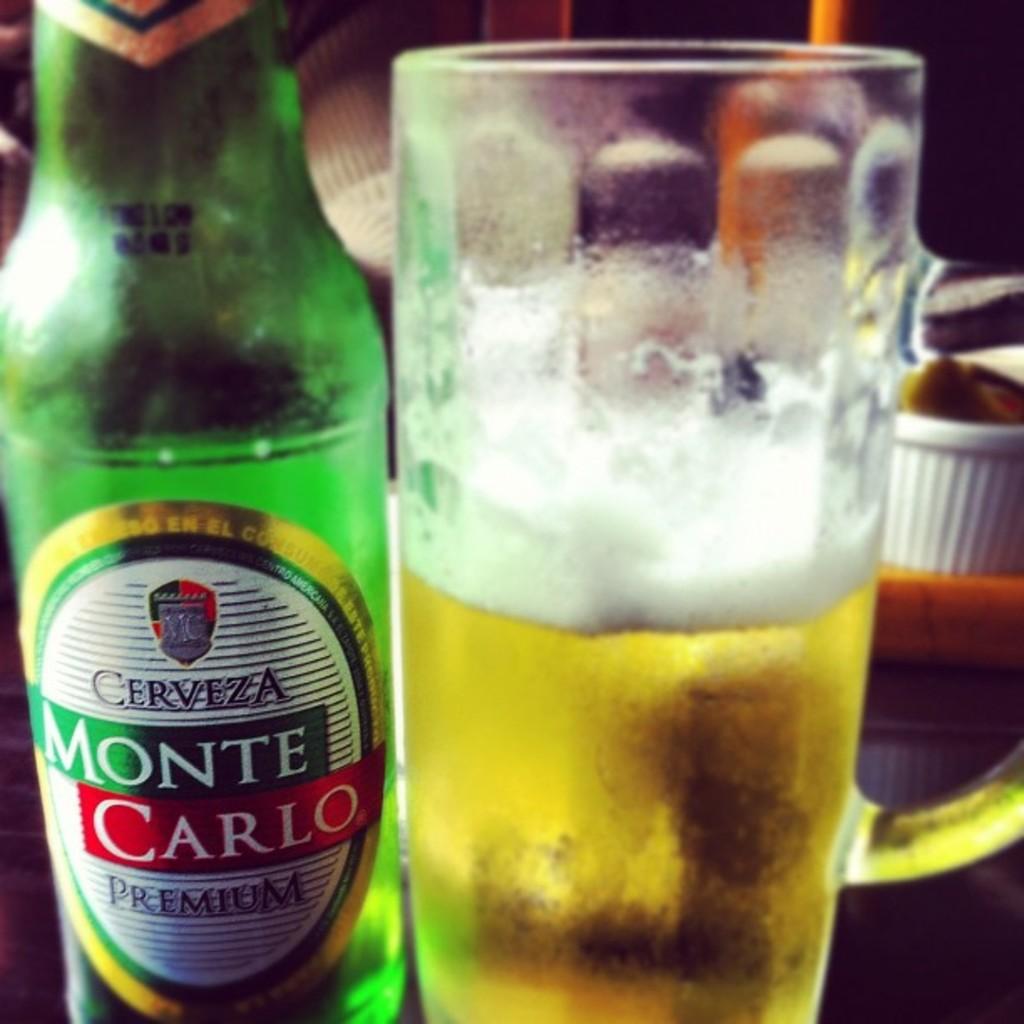What is the name of the beer in the green bottle?
Make the answer very short. Monte carlo. Is this a premium beer?
Keep it short and to the point. Yes. 